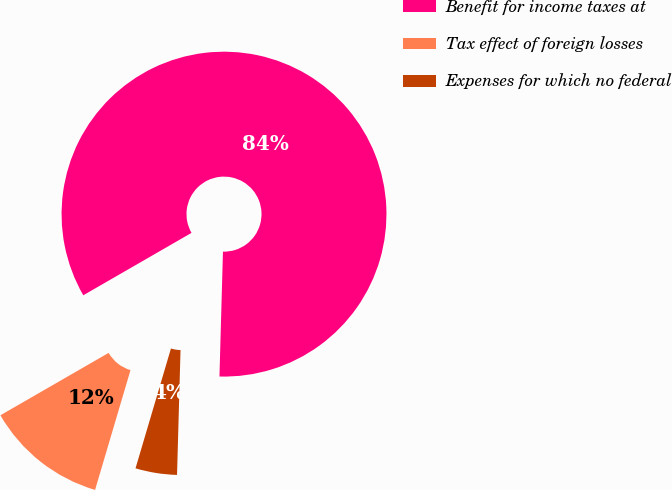Convert chart. <chart><loc_0><loc_0><loc_500><loc_500><pie_chart><fcel>Benefit for income taxes at<fcel>Tax effect of foreign losses<fcel>Expenses for which no federal<nl><fcel>83.77%<fcel>12.1%<fcel>4.13%<nl></chart> 